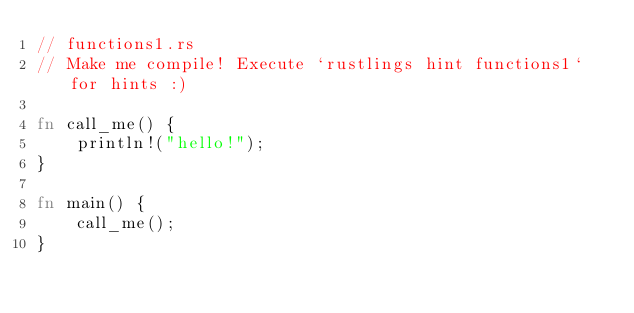<code> <loc_0><loc_0><loc_500><loc_500><_Rust_>// functions1.rs
// Make me compile! Execute `rustlings hint functions1` for hints :)

fn call_me() {
    println!("hello!");
}

fn main() {
    call_me();
}
</code> 